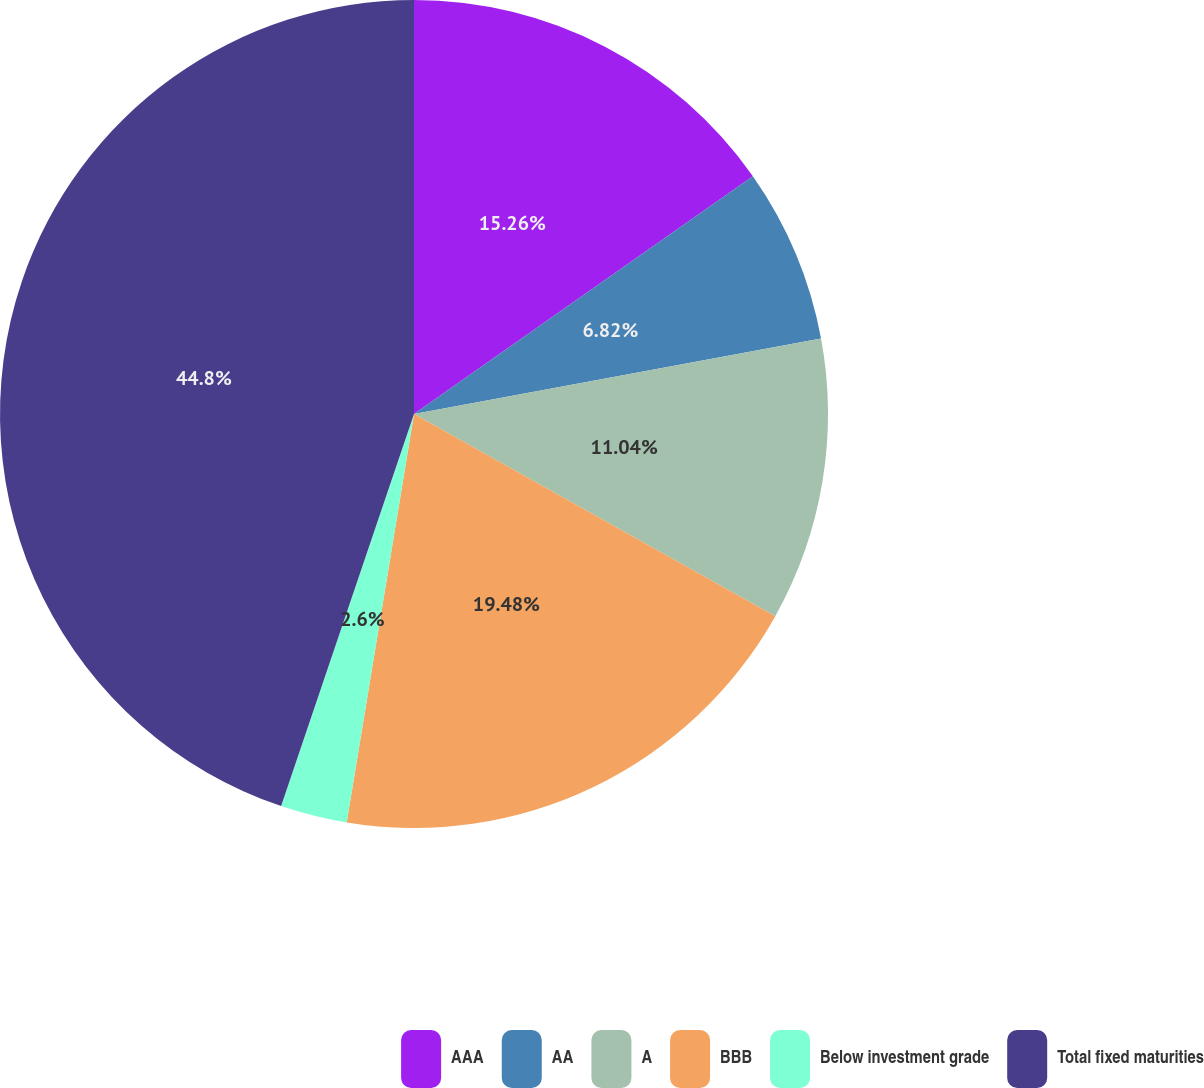<chart> <loc_0><loc_0><loc_500><loc_500><pie_chart><fcel>AAA<fcel>AA<fcel>A<fcel>BBB<fcel>Below investment grade<fcel>Total fixed maturities<nl><fcel>15.26%<fcel>6.82%<fcel>11.04%<fcel>19.48%<fcel>2.6%<fcel>44.8%<nl></chart> 